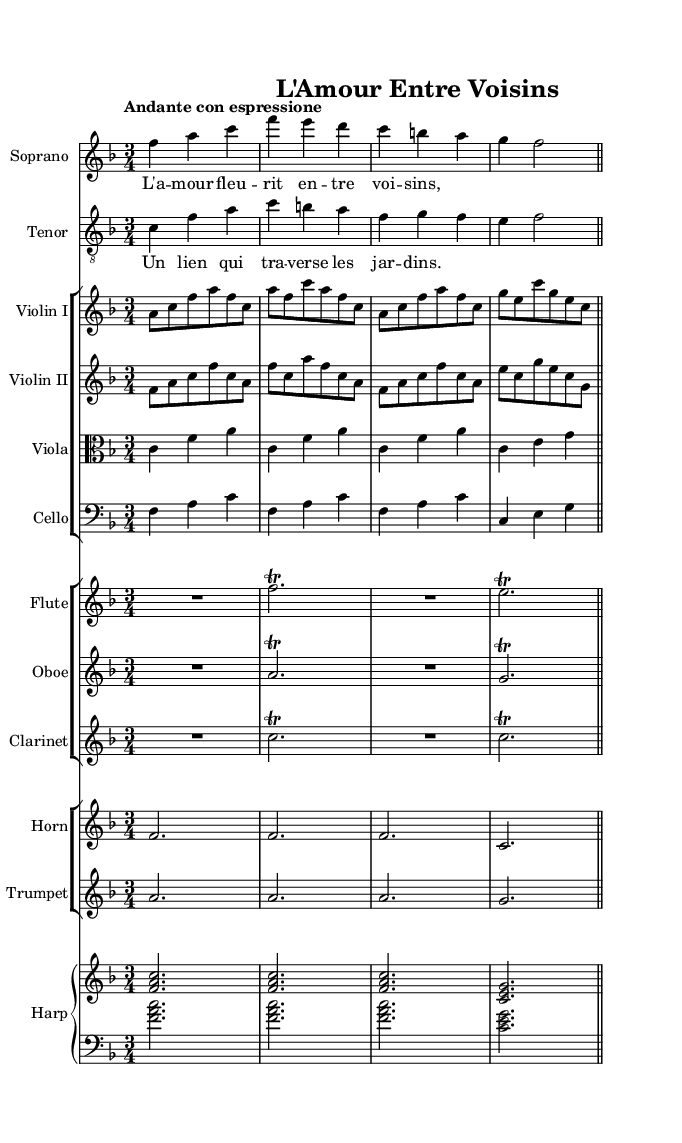What is the key signature of this music? The key signature is F major, which has one flat (B♭). It can be found in the music sheet at the beginning where there's a flat sign placed on the staff.
Answer: F major What is the time signature of this piece? The time signature is 3/4, indicated by the fraction at the beginning of the score. This means there are three beats in each measure, and the quarter note gets one beat.
Answer: 3/4 What is the tempo marking of this composition? The tempo marking is "Andante con espressione," which indicates a moderate pace with expression. This can be found at the beginning of the music where the tempo indication is given.
Answer: Andante con espressione How many instruments are indicated in the score? There are eight instruments indicated: soprano, tenor, two violins, viola, cello, flute, oboe, clarinet, horn, trumpet, and harp. Each instrument is listed at the beginning of their respective staffs.
Answer: Eight Which voice parts are featured prominently in the piece? The voice parts featured prominently are soprano and tenor, as indicated at the beginning of the score. These parts carry the melody and are accompanied by the instrumental sections.
Answer: Soprano and tenor What is the lyrical theme of the piece? The lyrical theme revolves around love, as suggested by the text of the soprano and tenor, which translates to "Love flourishes between neighbors" and "A bond that traverses the gardens." This indicates the central theme of connection and romance.
Answer: Love How many measures are in the vocal sections? The vocal sections consist of four measures each for the soprano and tenor parts. Each voice begins its line with a measure count that corresponds to its individual melodic phrase.
Answer: Four 